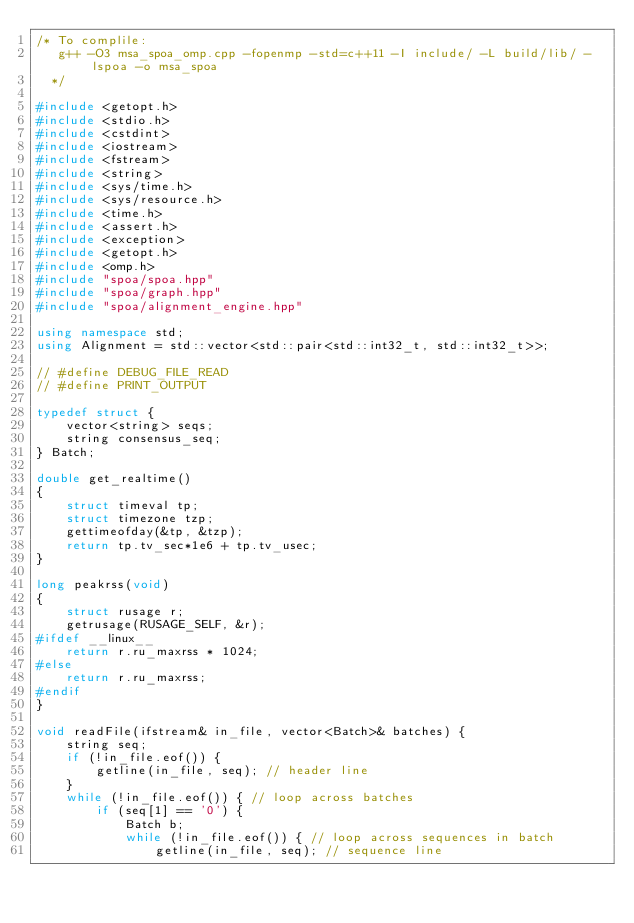Convert code to text. <code><loc_0><loc_0><loc_500><loc_500><_C++_>/* To complile:
   g++ -O3 msa_spoa_omp.cpp -fopenmp -std=c++11 -I include/ -L build/lib/ -lspoa -o msa_spoa
  */

#include <getopt.h>
#include <stdio.h>
#include <cstdint>
#include <iostream>
#include <fstream>
#include <string>
#include <sys/time.h>
#include <sys/resource.h>
#include <time.h>
#include <assert.h>
#include <exception>
#include <getopt.h>
#include <omp.h>
#include "spoa/spoa.hpp"
#include "spoa/graph.hpp"
#include "spoa/alignment_engine.hpp"

using namespace std;
using Alignment = std::vector<std::pair<std::int32_t, std::int32_t>>;

// #define DEBUG_FILE_READ
// #define PRINT_OUTPUT

typedef struct {
    vector<string> seqs;
    string consensus_seq;
} Batch;

double get_realtime()
{
	struct timeval tp;
	struct timezone tzp;
	gettimeofday(&tp, &tzp);
	return tp.tv_sec*1e6 + tp.tv_usec;
}

long peakrss(void)
{
	struct rusage r;
	getrusage(RUSAGE_SELF, &r);
#ifdef __linux__
	return r.ru_maxrss * 1024;
#else
	return r.ru_maxrss;
#endif
}

void readFile(ifstream& in_file, vector<Batch>& batches) {
    string seq;
    if (!in_file.eof()) {
        getline(in_file, seq); // header line
    }
    while (!in_file.eof()) { // loop across batches
        if (seq[1] == '0') {
            Batch b;
            while (!in_file.eof()) { // loop across sequences in batch
                getline(in_file, seq); // sequence line</code> 